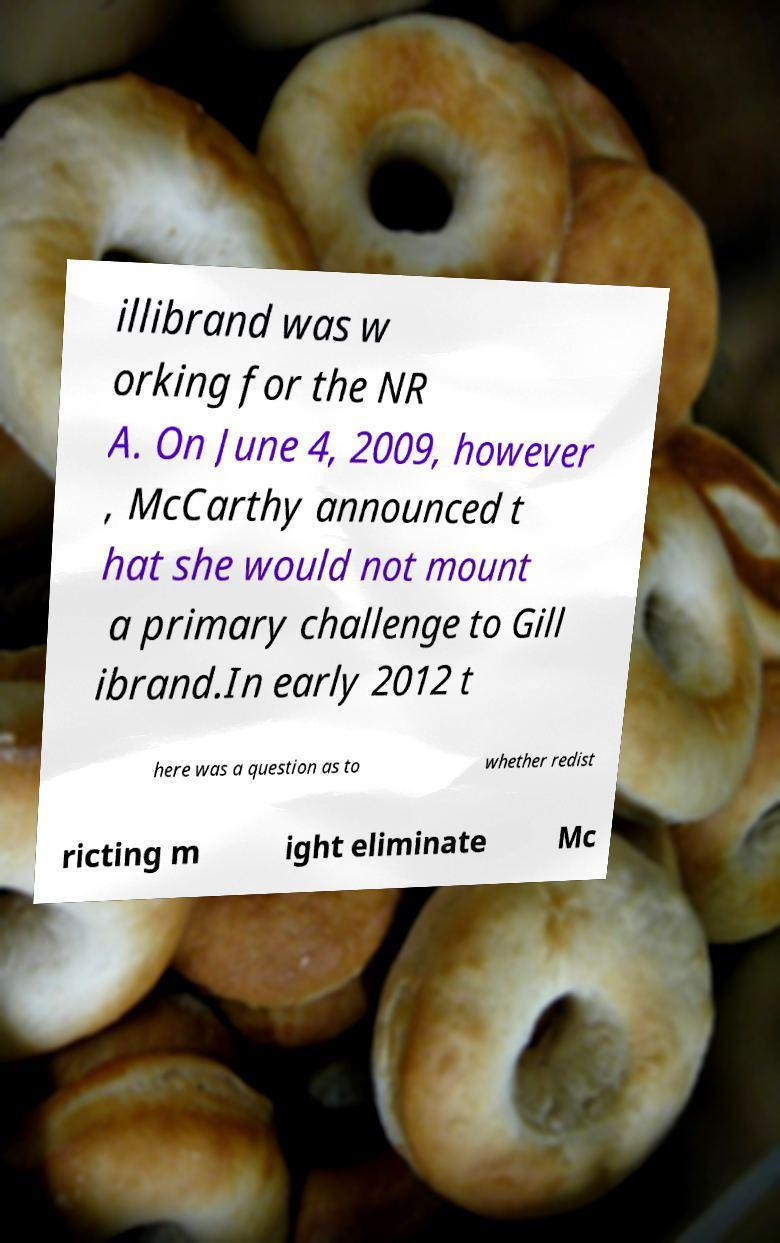Could you extract and type out the text from this image? illibrand was w orking for the NR A. On June 4, 2009, however , McCarthy announced t hat she would not mount a primary challenge to Gill ibrand.In early 2012 t here was a question as to whether redist ricting m ight eliminate Mc 